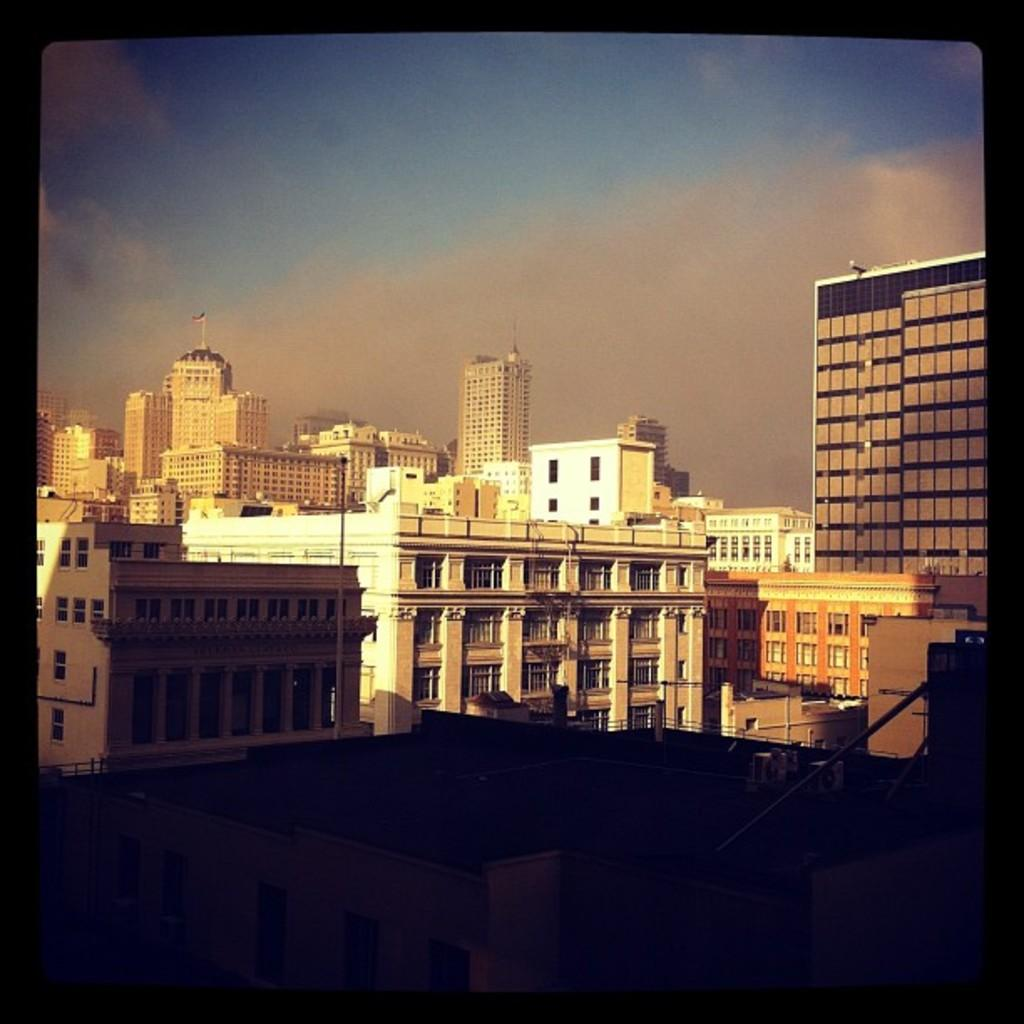What structures are present in the image? There are buildings in the image. What feature can be seen on the buildings? The buildings have windows. What part of the natural environment is visible in the image? The sky is visible in the image. What can be observed in the sky? There are clouds in the sky. What type of honey is being discussed by the clouds in the image? There is no honey or discussion present in the image; it features buildings with windows and clouds in the sky. What type of silk is draped over the buildings in the image? There is no silk present in the image; it features buildings with windows and clouds in the sky. 